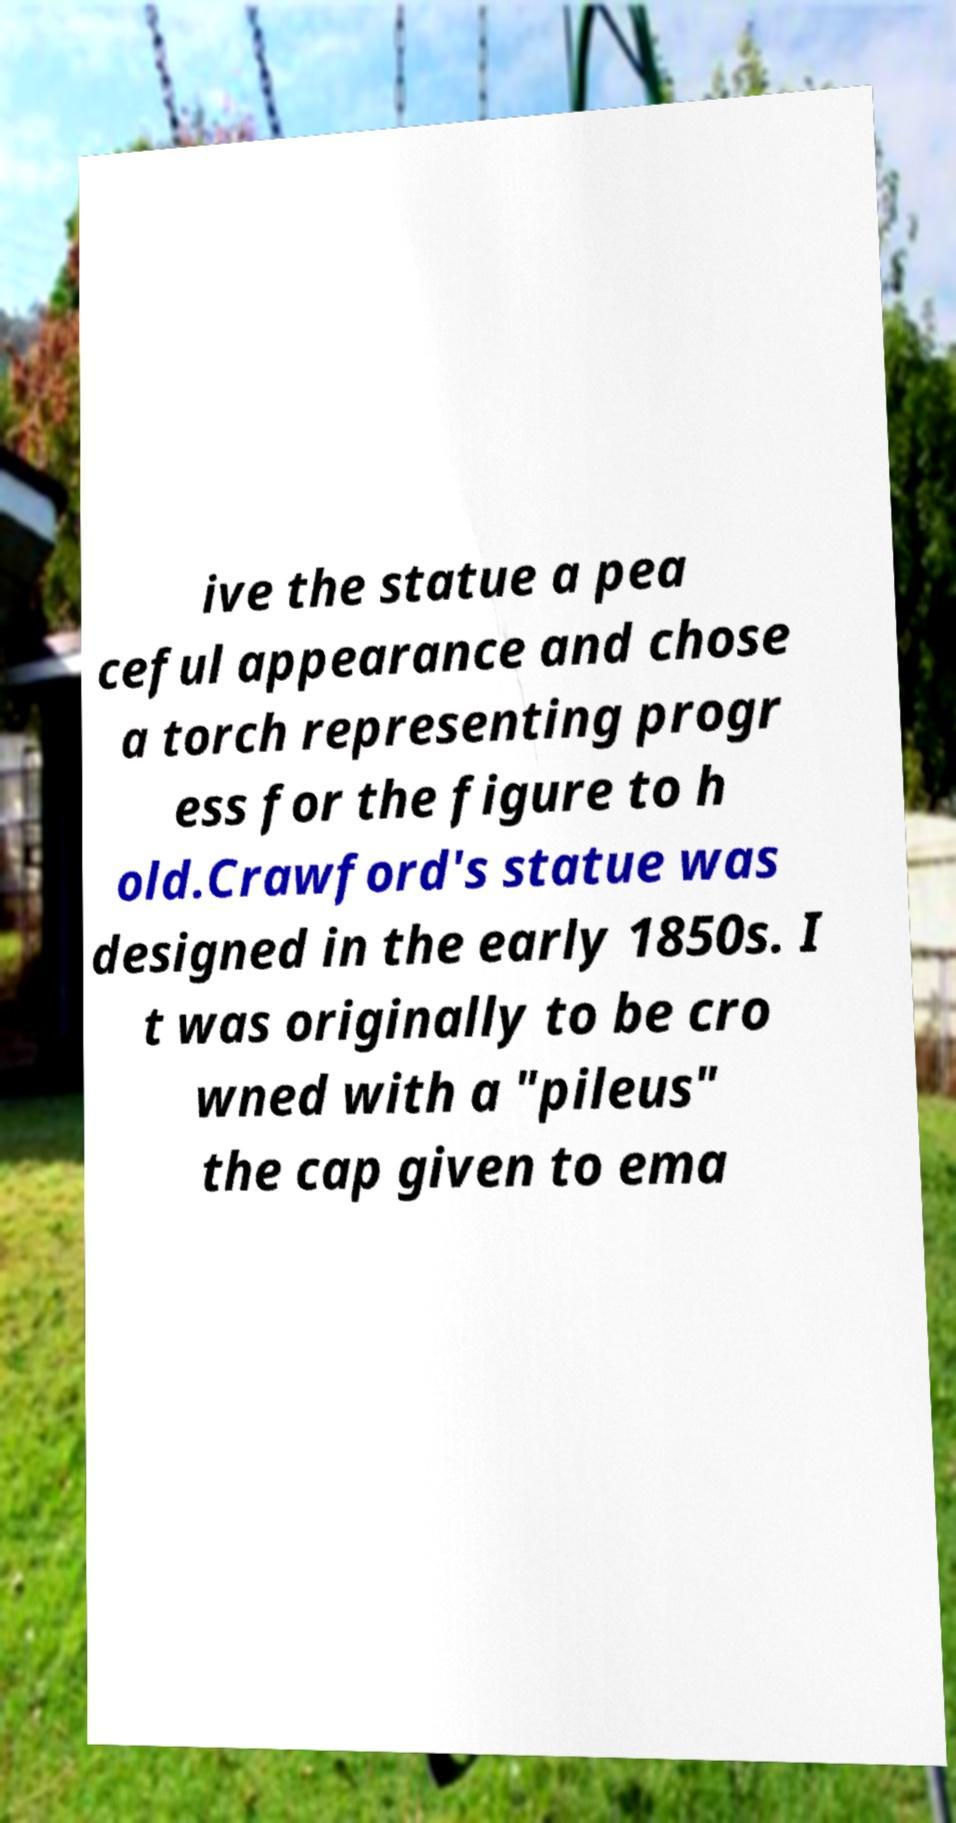Can you read and provide the text displayed in the image?This photo seems to have some interesting text. Can you extract and type it out for me? ive the statue a pea ceful appearance and chose a torch representing progr ess for the figure to h old.Crawford's statue was designed in the early 1850s. I t was originally to be cro wned with a "pileus" the cap given to ema 